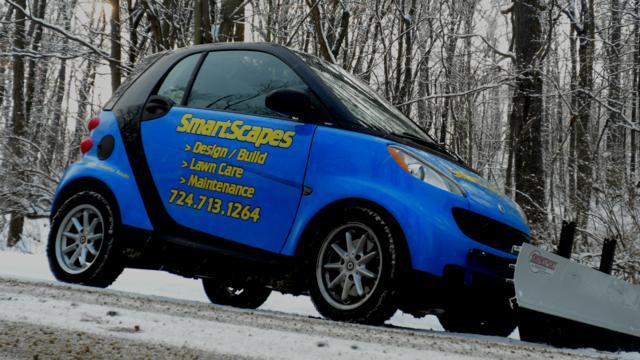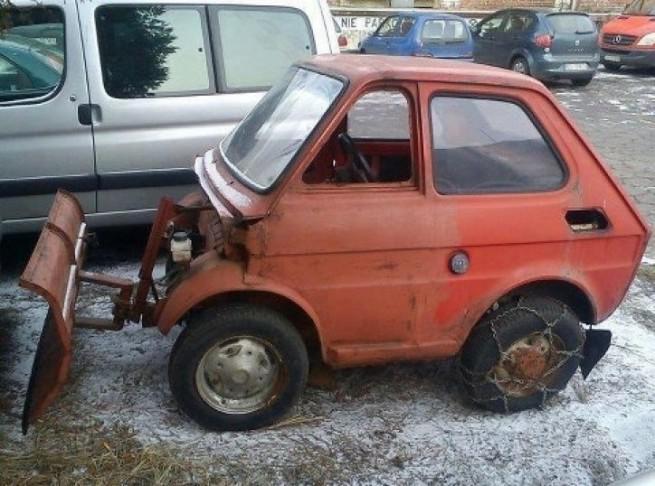The first image is the image on the left, the second image is the image on the right. Assess this claim about the two images: "An image shows a smart-car shaped orange vehicle with a plow attachment.". Correct or not? Answer yes or no. Yes. The first image is the image on the left, the second image is the image on the right. Assess this claim about the two images: "there is a yellow smart car with a plow blade on the front". Correct or not? Answer yes or no. No. 